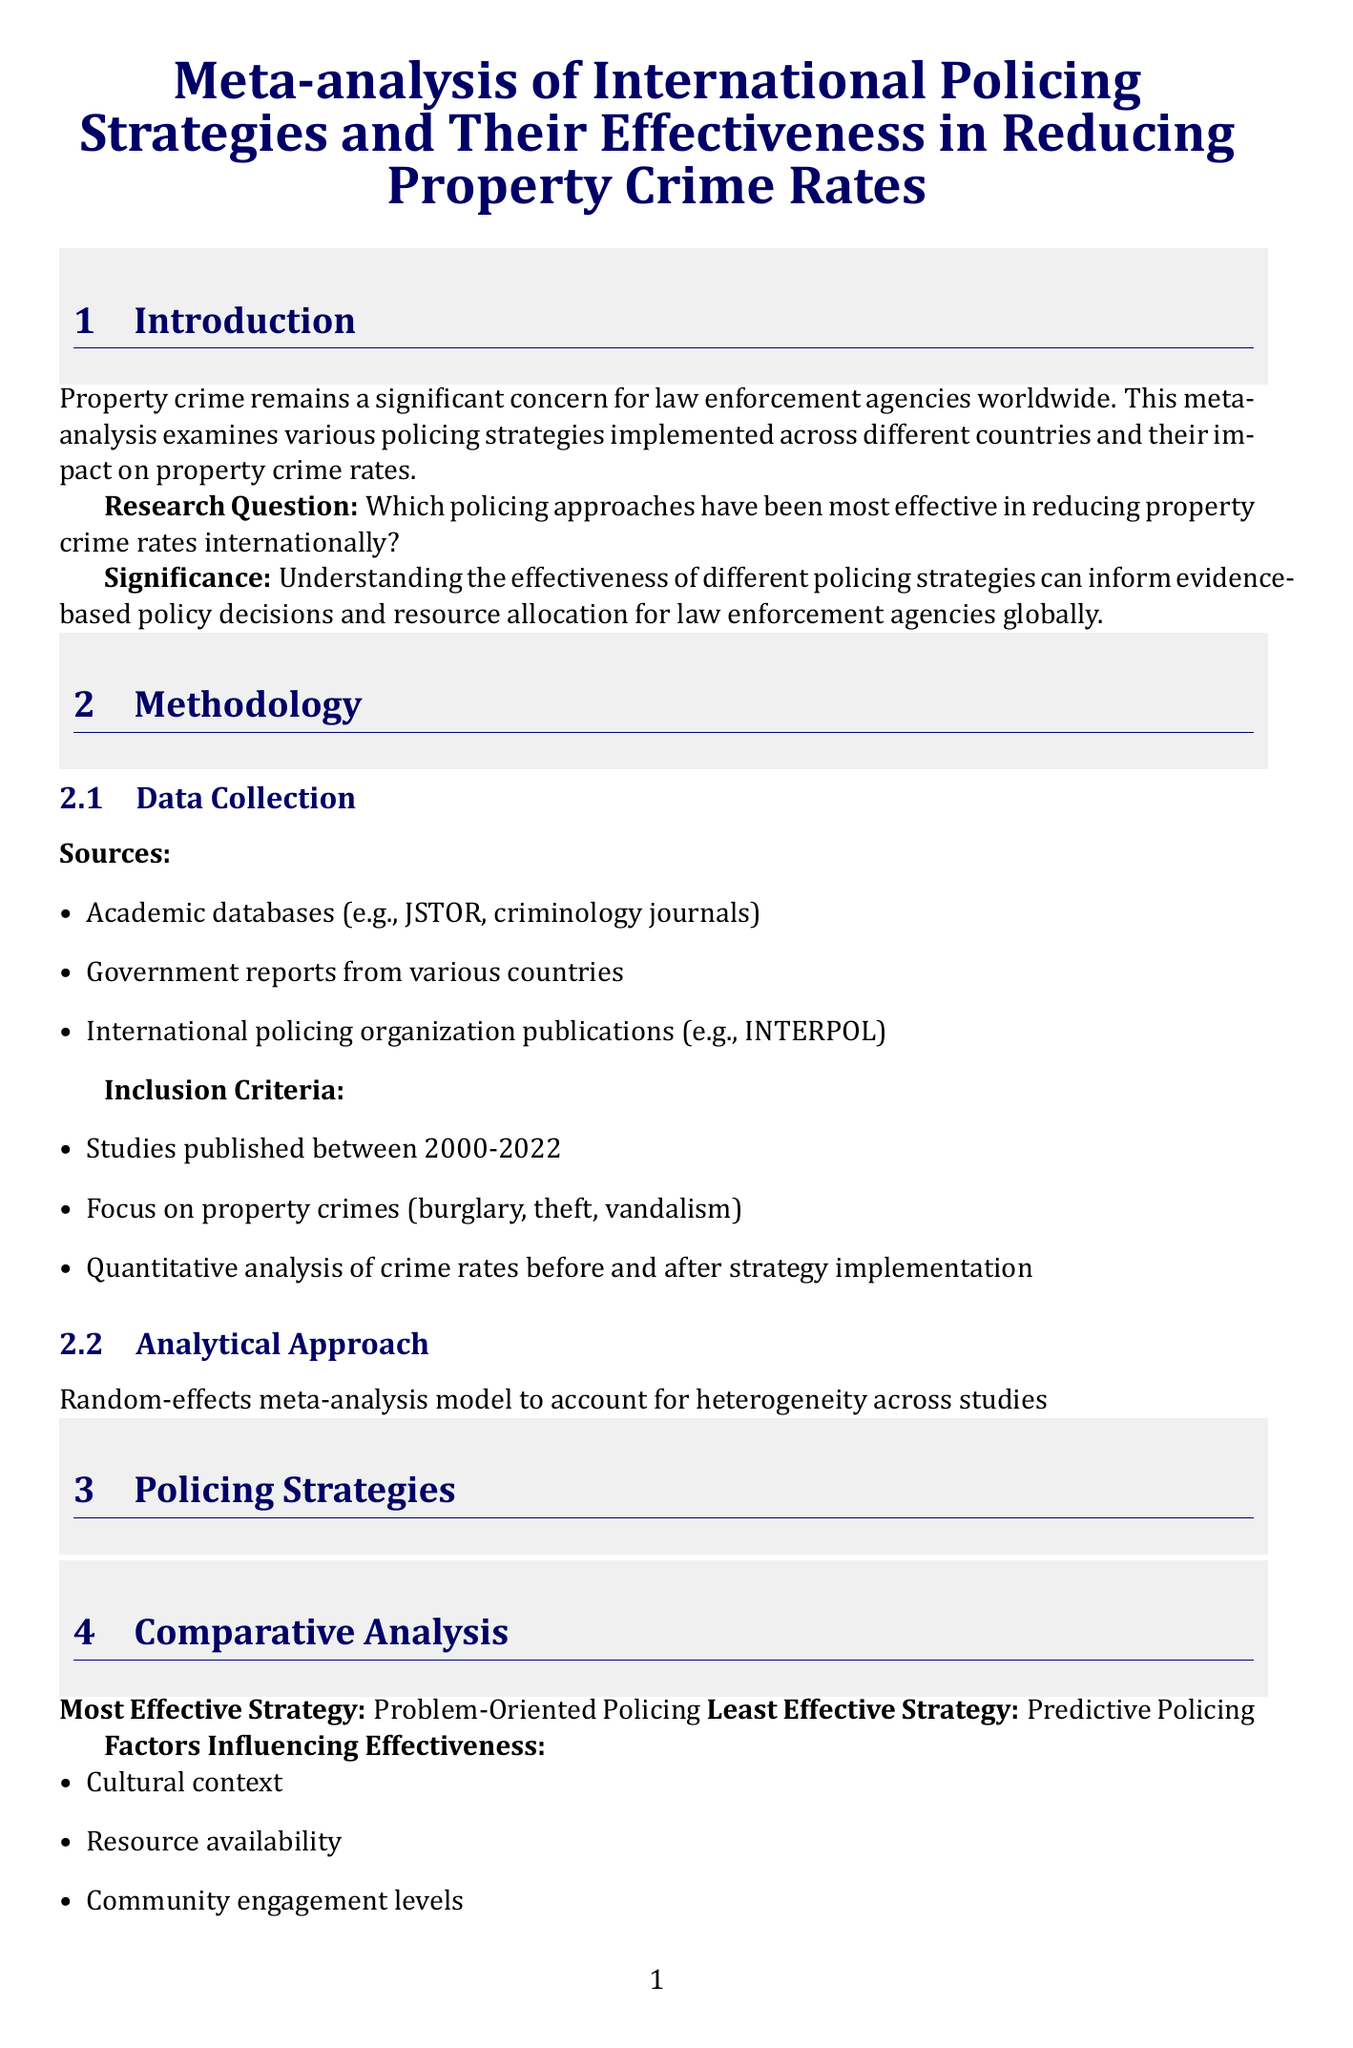What is the title of the report? The title is specified in the document's introduction section, presenting the main focus of the analysis.
Answer: Meta-analysis of International Policing Strategies and Their Effectiveness in Reducing Property Crime Rates What is the average reduction in property crime for Problem-Oriented Policing? This information is found in the table under the policing strategies section, which summarizes the effectiveness of various strategies.
Answer: 25% Which policing strategy is identified as the least effective? The comparative analysis section directly states which strategy has the lowest effectiveness based on the findings presented in the report.
Answer: Predictive Policing In which country was the Dutch Neighborhood Watch program implemented? The case studies section outlines specific examples of policing strategies in various countries, highlighting the program's geographical context.
Answer: Netherlands What year range does the inclusion criteria cover for the studies analyzed? This is mentioned in the methodology under data collection, specifying the time frame for the selected studies.
Answer: 2000-2022 What are two factors influencing the effectiveness of policing strategies? The comparative analysis section lists several factors that were determined to impact the effectiveness of the strategies discussed.
Answer: Cultural context, Resource availability What type of analytical approach was used in the meta-analysis? This detail is found in the methodology section, describing the statistical method employed to analyze the collected data.
Answer: Random-effects meta-analysis model Which case study indicated a 40% reduction in repeat victimization for burglary? The information regarding specific case study outcomes is presented in the case studies section, detailing the results of the identified program.
Answer: Australia 